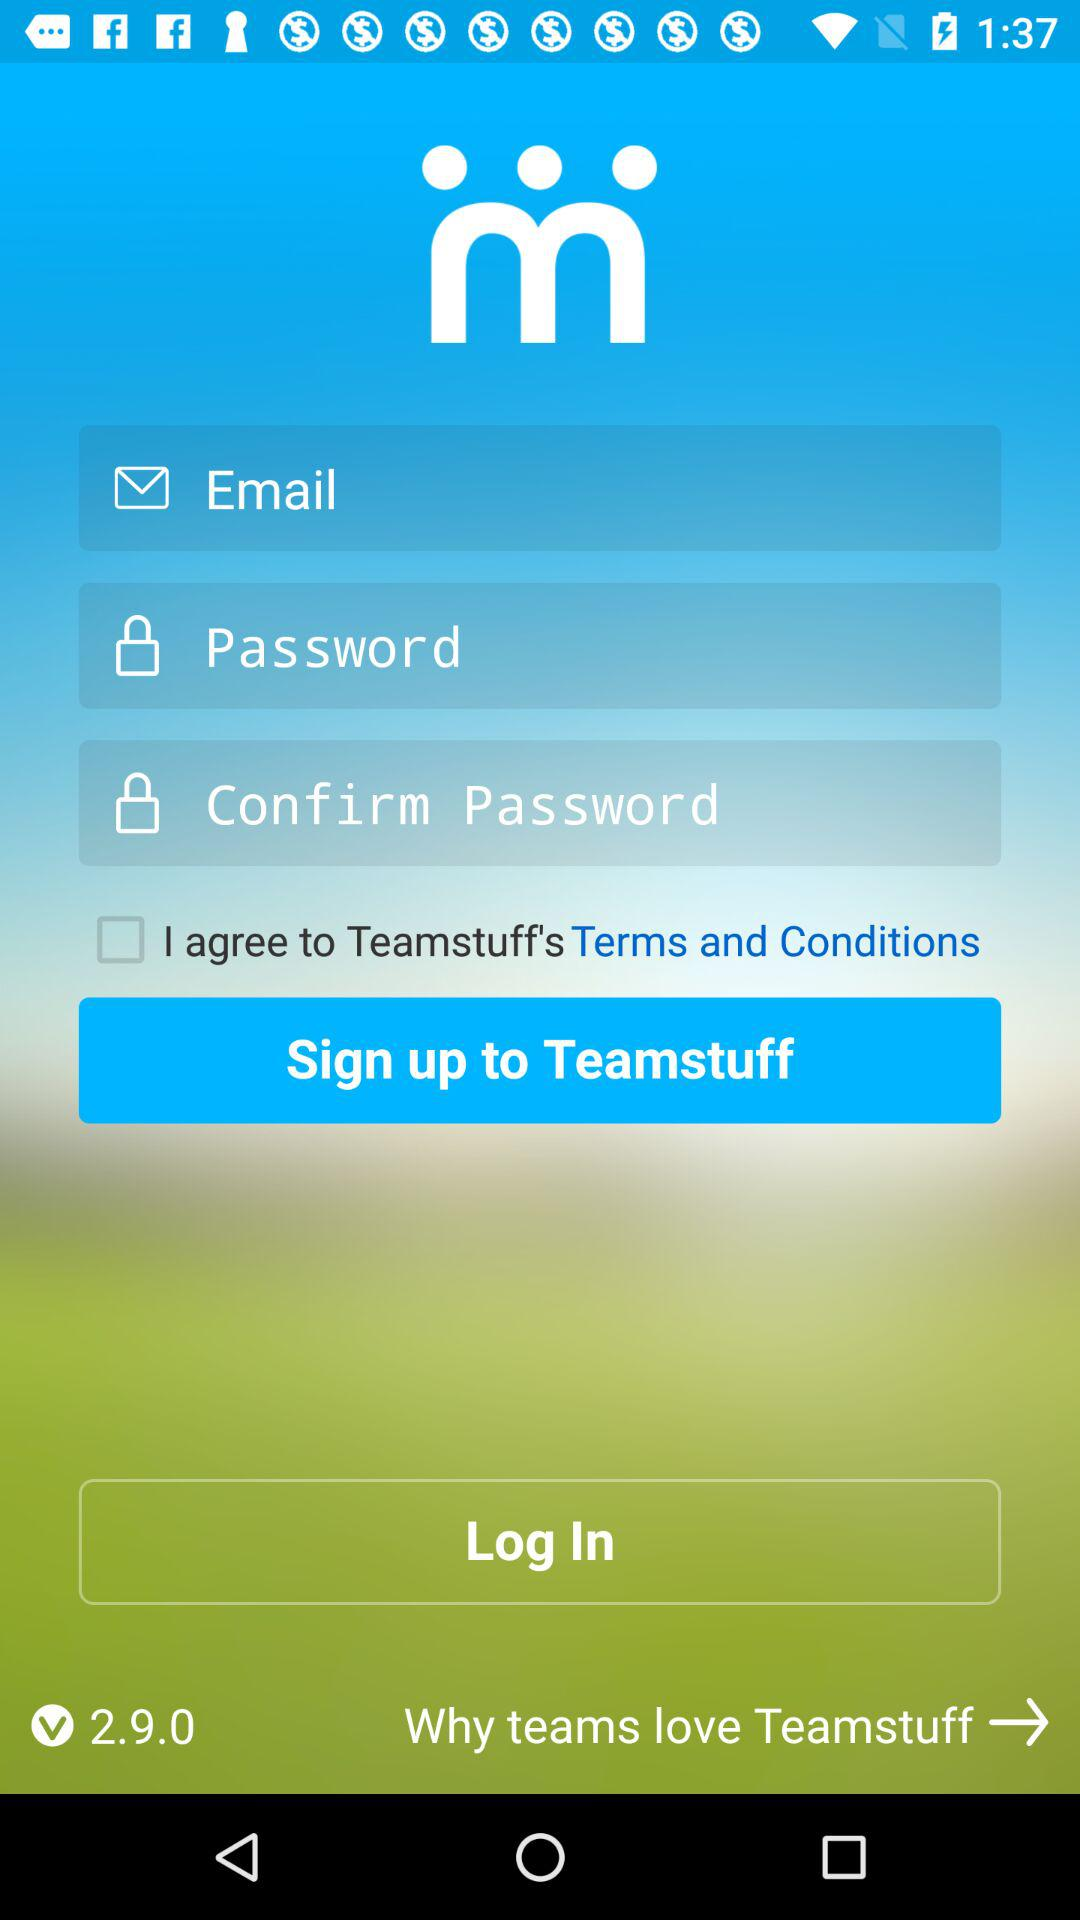What is the current status of the "I agree to Teamstuff's Terms and Conditions"? The current status is "off". 